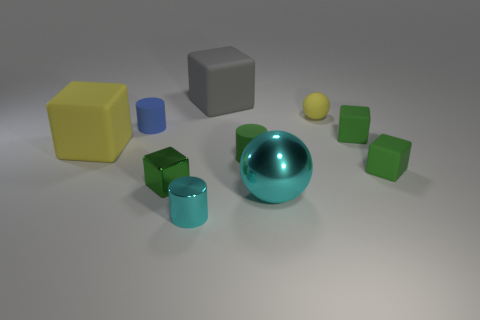Is the small green thing behind the big yellow object made of the same material as the big ball?
Ensure brevity in your answer.  No. How many green things are the same material as the tiny green cylinder?
Ensure brevity in your answer.  2. Is the number of large yellow rubber blocks that are behind the big metal object greater than the number of blue balls?
Ensure brevity in your answer.  Yes. What size is the rubber thing that is the same color as the tiny rubber sphere?
Make the answer very short. Large. Are there any big gray matte objects that have the same shape as the small blue object?
Keep it short and to the point. No. What number of things are green rubber cubes or gray things?
Make the answer very short. 3. There is a big cube in front of the matte cube that is behind the tiny ball; how many yellow objects are to the right of it?
Provide a short and direct response. 1. There is a yellow object that is the same shape as the big cyan metallic thing; what is it made of?
Give a very brief answer. Rubber. What is the material of the object that is in front of the blue thing and left of the green metallic block?
Your response must be concise. Rubber. Are there fewer big spheres that are to the left of the blue cylinder than green matte blocks that are behind the big cyan shiny thing?
Your answer should be very brief. Yes. 